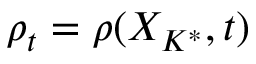Convert formula to latex. <formula><loc_0><loc_0><loc_500><loc_500>\rho _ { t } = \rho ( X _ { K ^ { * } } , t )</formula> 